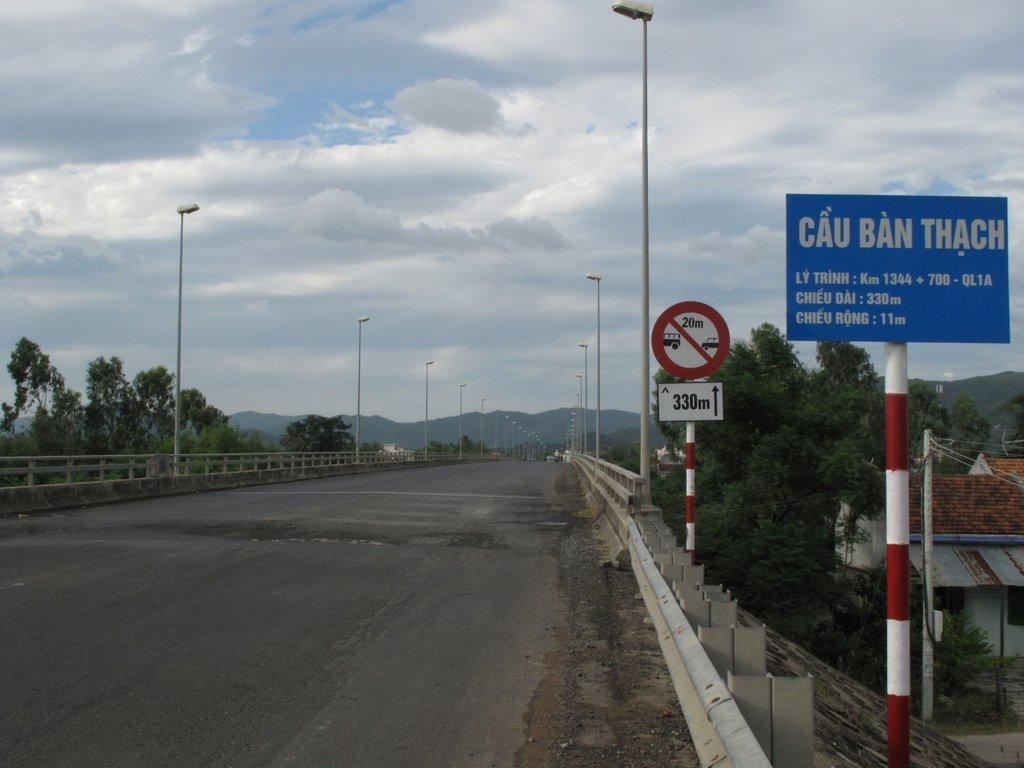<image>
Share a concise interpretation of the image provided. A blue and white sing on a red and white pole with the words cau ban thach on the top. 